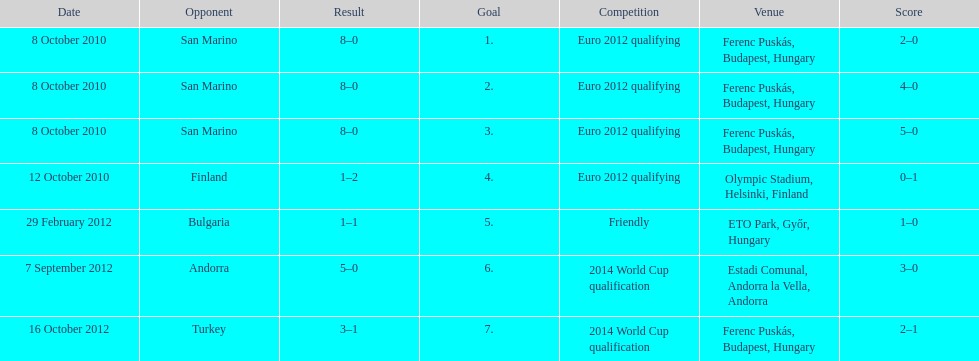What is the number of goals ádám szalai made against san marino in 2010? 3. 